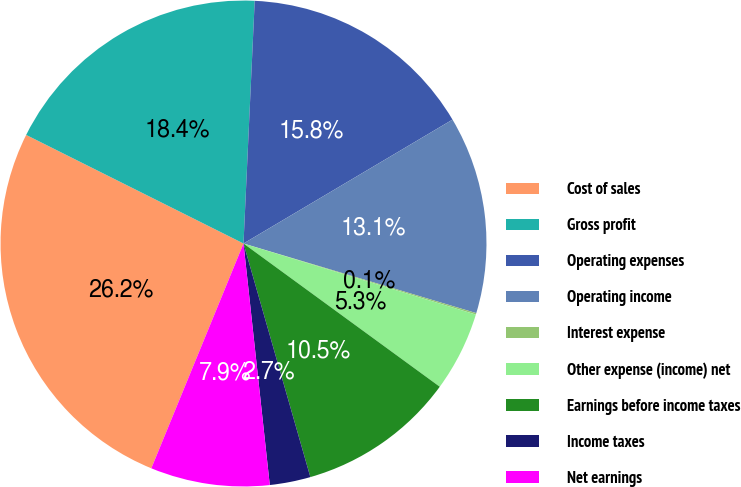<chart> <loc_0><loc_0><loc_500><loc_500><pie_chart><fcel>Cost of sales<fcel>Gross profit<fcel>Operating expenses<fcel>Operating income<fcel>Interest expense<fcel>Other expense (income) net<fcel>Earnings before income taxes<fcel>Income taxes<fcel>Net earnings<nl><fcel>26.18%<fcel>18.36%<fcel>15.75%<fcel>13.14%<fcel>0.1%<fcel>5.31%<fcel>10.53%<fcel>2.71%<fcel>7.92%<nl></chart> 